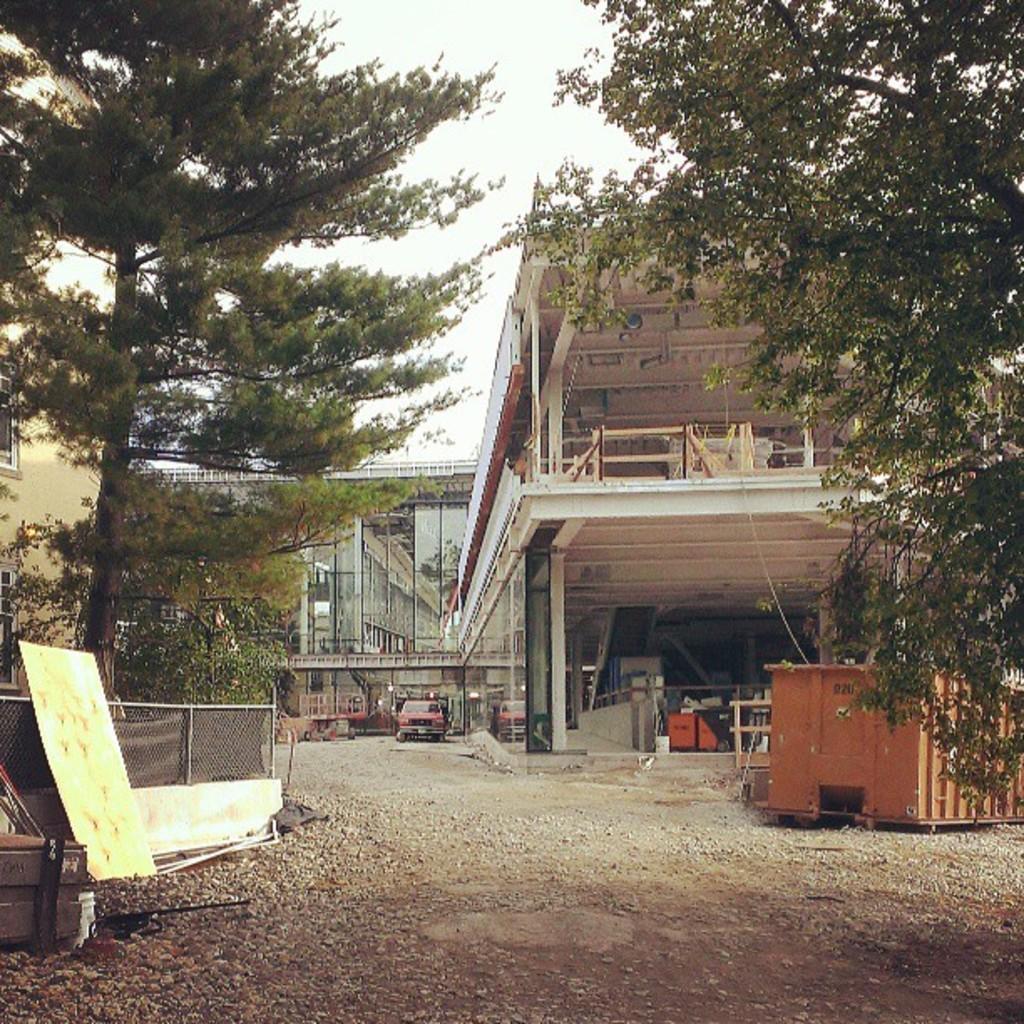Please provide a concise description of this image. As we can see in the image there are trees, buildings, fence, vehicle and sky. 